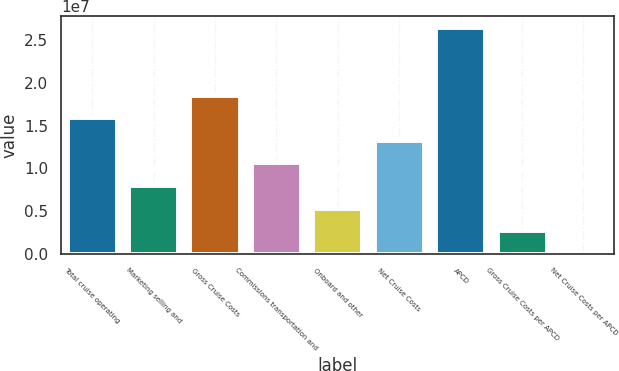Convert chart to OTSL. <chart><loc_0><loc_0><loc_500><loc_500><bar_chart><fcel>Total cruise operating<fcel>Marketing selling and<fcel>Gross Cruise Costs<fcel>Commissions transportation and<fcel>Onboard and other<fcel>Net Cruise Costs<fcel>APCD<fcel>Gross Cruise Costs per APCD<fcel>Net Cruise Costs per APCD<nl><fcel>1.58782e+07<fcel>7.93918e+06<fcel>1.85246e+07<fcel>1.05855e+07<fcel>5.29283e+06<fcel>1.32319e+07<fcel>2.64636e+07<fcel>2.64648e+06<fcel>133.37<nl></chart> 